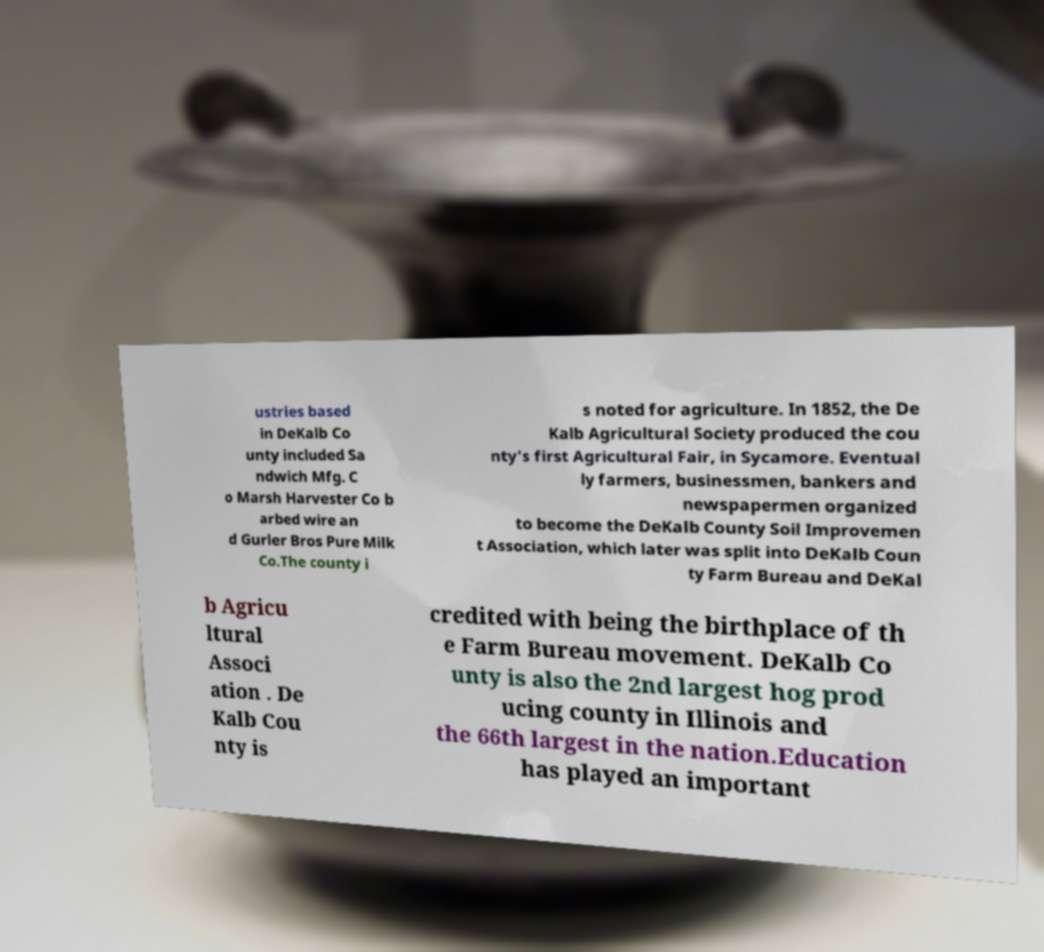Can you accurately transcribe the text from the provided image for me? ustries based in DeKalb Co unty included Sa ndwich Mfg. C o Marsh Harvester Co b arbed wire an d Gurler Bros Pure Milk Co.The county i s noted for agriculture. In 1852, the De Kalb Agricultural Society produced the cou nty's first Agricultural Fair, in Sycamore. Eventual ly farmers, businessmen, bankers and newspapermen organized to become the DeKalb County Soil Improvemen t Association, which later was split into DeKalb Coun ty Farm Bureau and DeKal b Agricu ltural Associ ation . De Kalb Cou nty is credited with being the birthplace of th e Farm Bureau movement. DeKalb Co unty is also the 2nd largest hog prod ucing county in Illinois and the 66th largest in the nation.Education has played an important 